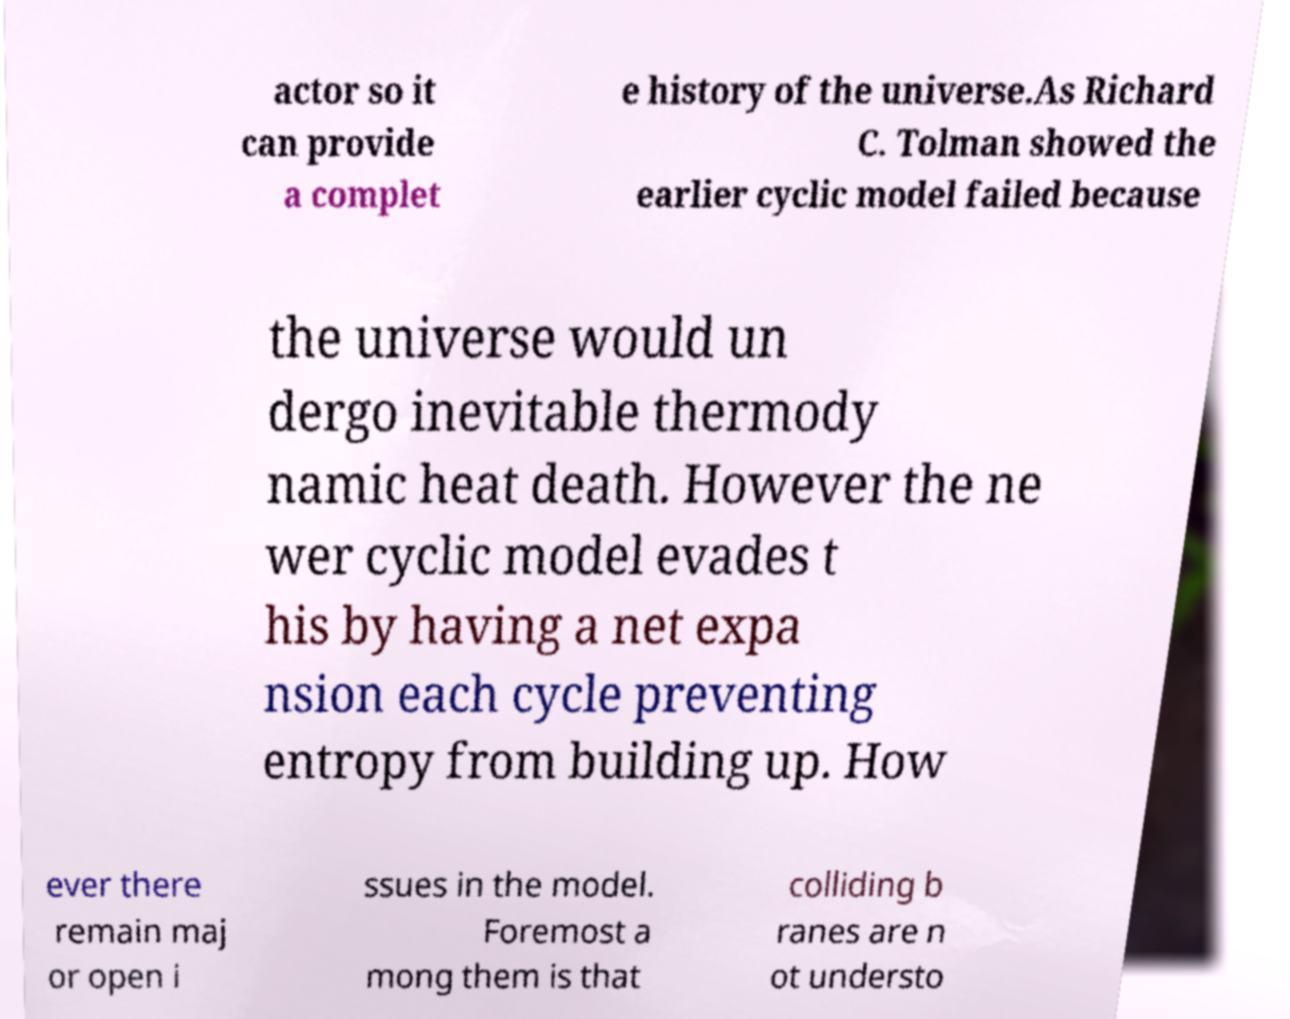For documentation purposes, I need the text within this image transcribed. Could you provide that? actor so it can provide a complet e history of the universe.As Richard C. Tolman showed the earlier cyclic model failed because the universe would un dergo inevitable thermody namic heat death. However the ne wer cyclic model evades t his by having a net expa nsion each cycle preventing entropy from building up. How ever there remain maj or open i ssues in the model. Foremost a mong them is that colliding b ranes are n ot understo 